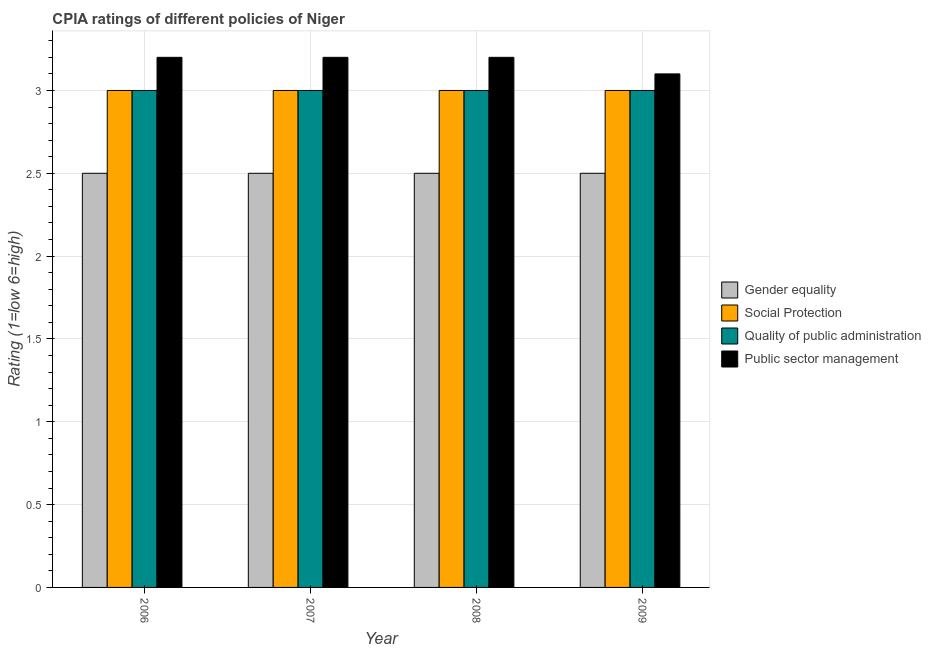How many different coloured bars are there?
Provide a short and direct response. 4. How many groups of bars are there?
Your answer should be very brief. 4. Are the number of bars on each tick of the X-axis equal?
Your response must be concise. Yes. How many bars are there on the 3rd tick from the right?
Give a very brief answer. 4. What is the label of the 2nd group of bars from the left?
Ensure brevity in your answer.  2007. What is the cpia rating of social protection in 2009?
Provide a short and direct response. 3. Across all years, what is the maximum cpia rating of public sector management?
Your response must be concise. 3.2. Across all years, what is the minimum cpia rating of gender equality?
Provide a succinct answer. 2.5. In which year was the cpia rating of social protection maximum?
Your answer should be very brief. 2006. What is the total cpia rating of quality of public administration in the graph?
Keep it short and to the point. 12. What is the average cpia rating of gender equality per year?
Offer a terse response. 2.5. In the year 2007, what is the difference between the cpia rating of gender equality and cpia rating of quality of public administration?
Offer a terse response. 0. Is the difference between the cpia rating of quality of public administration in 2006 and 2008 greater than the difference between the cpia rating of gender equality in 2006 and 2008?
Your answer should be very brief. No. What is the difference between the highest and the second highest cpia rating of public sector management?
Keep it short and to the point. 0. Is the sum of the cpia rating of quality of public administration in 2008 and 2009 greater than the maximum cpia rating of social protection across all years?
Make the answer very short. Yes. Is it the case that in every year, the sum of the cpia rating of social protection and cpia rating of public sector management is greater than the sum of cpia rating of quality of public administration and cpia rating of gender equality?
Your answer should be very brief. No. What does the 4th bar from the left in 2006 represents?
Make the answer very short. Public sector management. What does the 1st bar from the right in 2006 represents?
Give a very brief answer. Public sector management. How many bars are there?
Provide a short and direct response. 16. Are all the bars in the graph horizontal?
Your response must be concise. No. How many years are there in the graph?
Your answer should be very brief. 4. Are the values on the major ticks of Y-axis written in scientific E-notation?
Offer a very short reply. No. Does the graph contain any zero values?
Offer a very short reply. No. Where does the legend appear in the graph?
Your answer should be very brief. Center right. How are the legend labels stacked?
Offer a very short reply. Vertical. What is the title of the graph?
Make the answer very short. CPIA ratings of different policies of Niger. Does "Coal" appear as one of the legend labels in the graph?
Keep it short and to the point. No. What is the Rating (1=low 6=high) in Quality of public administration in 2006?
Give a very brief answer. 3. What is the Rating (1=low 6=high) in Gender equality in 2007?
Offer a very short reply. 2.5. What is the Rating (1=low 6=high) in Gender equality in 2008?
Offer a very short reply. 2.5. What is the Rating (1=low 6=high) in Quality of public administration in 2008?
Provide a succinct answer. 3. What is the Rating (1=low 6=high) in Public sector management in 2008?
Your answer should be compact. 3.2. What is the Rating (1=low 6=high) in Quality of public administration in 2009?
Your response must be concise. 3. Across all years, what is the maximum Rating (1=low 6=high) of Gender equality?
Your response must be concise. 2.5. Across all years, what is the maximum Rating (1=low 6=high) of Public sector management?
Give a very brief answer. 3.2. Across all years, what is the minimum Rating (1=low 6=high) of Quality of public administration?
Your answer should be very brief. 3. What is the total Rating (1=low 6=high) of Social Protection in the graph?
Provide a short and direct response. 12. What is the total Rating (1=low 6=high) of Quality of public administration in the graph?
Keep it short and to the point. 12. What is the total Rating (1=low 6=high) of Public sector management in the graph?
Provide a short and direct response. 12.7. What is the difference between the Rating (1=low 6=high) in Quality of public administration in 2006 and that in 2007?
Give a very brief answer. 0. What is the difference between the Rating (1=low 6=high) of Public sector management in 2006 and that in 2007?
Offer a very short reply. 0. What is the difference between the Rating (1=low 6=high) of Gender equality in 2006 and that in 2008?
Your answer should be compact. 0. What is the difference between the Rating (1=low 6=high) of Social Protection in 2006 and that in 2008?
Offer a very short reply. 0. What is the difference between the Rating (1=low 6=high) in Gender equality in 2006 and that in 2009?
Provide a short and direct response. 0. What is the difference between the Rating (1=low 6=high) in Social Protection in 2006 and that in 2009?
Give a very brief answer. 0. What is the difference between the Rating (1=low 6=high) of Public sector management in 2006 and that in 2009?
Offer a very short reply. 0.1. What is the difference between the Rating (1=low 6=high) of Gender equality in 2007 and that in 2008?
Ensure brevity in your answer.  0. What is the difference between the Rating (1=low 6=high) of Social Protection in 2007 and that in 2008?
Provide a succinct answer. 0. What is the difference between the Rating (1=low 6=high) of Quality of public administration in 2007 and that in 2008?
Make the answer very short. 0. What is the difference between the Rating (1=low 6=high) of Gender equality in 2007 and that in 2009?
Provide a succinct answer. 0. What is the difference between the Rating (1=low 6=high) of Social Protection in 2007 and that in 2009?
Offer a terse response. 0. What is the difference between the Rating (1=low 6=high) of Public sector management in 2008 and that in 2009?
Your response must be concise. 0.1. What is the difference between the Rating (1=low 6=high) in Gender equality in 2006 and the Rating (1=low 6=high) in Social Protection in 2007?
Your answer should be very brief. -0.5. What is the difference between the Rating (1=low 6=high) of Gender equality in 2006 and the Rating (1=low 6=high) of Public sector management in 2008?
Provide a succinct answer. -0.7. What is the difference between the Rating (1=low 6=high) of Social Protection in 2006 and the Rating (1=low 6=high) of Public sector management in 2008?
Provide a short and direct response. -0.2. What is the difference between the Rating (1=low 6=high) in Gender equality in 2006 and the Rating (1=low 6=high) in Public sector management in 2009?
Ensure brevity in your answer.  -0.6. What is the difference between the Rating (1=low 6=high) in Social Protection in 2006 and the Rating (1=low 6=high) in Quality of public administration in 2009?
Keep it short and to the point. 0. What is the difference between the Rating (1=low 6=high) in Social Protection in 2006 and the Rating (1=low 6=high) in Public sector management in 2009?
Your response must be concise. -0.1. What is the difference between the Rating (1=low 6=high) in Gender equality in 2007 and the Rating (1=low 6=high) in Quality of public administration in 2008?
Ensure brevity in your answer.  -0.5. What is the difference between the Rating (1=low 6=high) in Gender equality in 2007 and the Rating (1=low 6=high) in Public sector management in 2008?
Provide a short and direct response. -0.7. What is the difference between the Rating (1=low 6=high) of Social Protection in 2007 and the Rating (1=low 6=high) of Quality of public administration in 2008?
Keep it short and to the point. 0. What is the difference between the Rating (1=low 6=high) of Quality of public administration in 2007 and the Rating (1=low 6=high) of Public sector management in 2008?
Offer a very short reply. -0.2. What is the difference between the Rating (1=low 6=high) of Gender equality in 2007 and the Rating (1=low 6=high) of Social Protection in 2009?
Offer a terse response. -0.5. What is the difference between the Rating (1=low 6=high) in Gender equality in 2007 and the Rating (1=low 6=high) in Quality of public administration in 2009?
Offer a very short reply. -0.5. What is the difference between the Rating (1=low 6=high) of Gender equality in 2007 and the Rating (1=low 6=high) of Public sector management in 2009?
Provide a short and direct response. -0.6. What is the difference between the Rating (1=low 6=high) of Quality of public administration in 2007 and the Rating (1=low 6=high) of Public sector management in 2009?
Keep it short and to the point. -0.1. What is the difference between the Rating (1=low 6=high) of Social Protection in 2008 and the Rating (1=low 6=high) of Quality of public administration in 2009?
Keep it short and to the point. 0. What is the difference between the Rating (1=low 6=high) in Social Protection in 2008 and the Rating (1=low 6=high) in Public sector management in 2009?
Keep it short and to the point. -0.1. What is the difference between the Rating (1=low 6=high) of Quality of public administration in 2008 and the Rating (1=low 6=high) of Public sector management in 2009?
Provide a short and direct response. -0.1. What is the average Rating (1=low 6=high) in Gender equality per year?
Your response must be concise. 2.5. What is the average Rating (1=low 6=high) of Social Protection per year?
Ensure brevity in your answer.  3. What is the average Rating (1=low 6=high) of Public sector management per year?
Offer a very short reply. 3.17. In the year 2006, what is the difference between the Rating (1=low 6=high) of Gender equality and Rating (1=low 6=high) of Public sector management?
Your answer should be compact. -0.7. In the year 2006, what is the difference between the Rating (1=low 6=high) of Social Protection and Rating (1=low 6=high) of Quality of public administration?
Keep it short and to the point. 0. In the year 2006, what is the difference between the Rating (1=low 6=high) of Social Protection and Rating (1=low 6=high) of Public sector management?
Offer a terse response. -0.2. In the year 2006, what is the difference between the Rating (1=low 6=high) in Quality of public administration and Rating (1=low 6=high) in Public sector management?
Provide a succinct answer. -0.2. In the year 2007, what is the difference between the Rating (1=low 6=high) of Gender equality and Rating (1=low 6=high) of Social Protection?
Provide a short and direct response. -0.5. In the year 2007, what is the difference between the Rating (1=low 6=high) in Social Protection and Rating (1=low 6=high) in Quality of public administration?
Keep it short and to the point. 0. In the year 2007, what is the difference between the Rating (1=low 6=high) of Quality of public administration and Rating (1=low 6=high) of Public sector management?
Provide a short and direct response. -0.2. In the year 2008, what is the difference between the Rating (1=low 6=high) of Gender equality and Rating (1=low 6=high) of Social Protection?
Provide a short and direct response. -0.5. In the year 2008, what is the difference between the Rating (1=low 6=high) in Gender equality and Rating (1=low 6=high) in Quality of public administration?
Offer a terse response. -0.5. In the year 2009, what is the difference between the Rating (1=low 6=high) in Social Protection and Rating (1=low 6=high) in Quality of public administration?
Ensure brevity in your answer.  0. In the year 2009, what is the difference between the Rating (1=low 6=high) in Social Protection and Rating (1=low 6=high) in Public sector management?
Make the answer very short. -0.1. In the year 2009, what is the difference between the Rating (1=low 6=high) of Quality of public administration and Rating (1=low 6=high) of Public sector management?
Provide a short and direct response. -0.1. What is the ratio of the Rating (1=low 6=high) of Social Protection in 2006 to that in 2007?
Offer a very short reply. 1. What is the ratio of the Rating (1=low 6=high) in Quality of public administration in 2006 to that in 2007?
Provide a succinct answer. 1. What is the ratio of the Rating (1=low 6=high) of Gender equality in 2006 to that in 2008?
Keep it short and to the point. 1. What is the ratio of the Rating (1=low 6=high) in Social Protection in 2006 to that in 2008?
Make the answer very short. 1. What is the ratio of the Rating (1=low 6=high) of Quality of public administration in 2006 to that in 2008?
Your answer should be very brief. 1. What is the ratio of the Rating (1=low 6=high) in Social Protection in 2006 to that in 2009?
Keep it short and to the point. 1. What is the ratio of the Rating (1=low 6=high) in Public sector management in 2006 to that in 2009?
Make the answer very short. 1.03. What is the ratio of the Rating (1=low 6=high) in Social Protection in 2007 to that in 2008?
Keep it short and to the point. 1. What is the ratio of the Rating (1=low 6=high) of Quality of public administration in 2007 to that in 2008?
Provide a succinct answer. 1. What is the ratio of the Rating (1=low 6=high) of Gender equality in 2007 to that in 2009?
Your response must be concise. 1. What is the ratio of the Rating (1=low 6=high) in Quality of public administration in 2007 to that in 2009?
Your answer should be compact. 1. What is the ratio of the Rating (1=low 6=high) of Public sector management in 2007 to that in 2009?
Your answer should be compact. 1.03. What is the ratio of the Rating (1=low 6=high) in Social Protection in 2008 to that in 2009?
Provide a short and direct response. 1. What is the ratio of the Rating (1=low 6=high) of Public sector management in 2008 to that in 2009?
Keep it short and to the point. 1.03. What is the difference between the highest and the second highest Rating (1=low 6=high) in Social Protection?
Offer a very short reply. 0. What is the difference between the highest and the lowest Rating (1=low 6=high) of Gender equality?
Provide a short and direct response. 0. What is the difference between the highest and the lowest Rating (1=low 6=high) of Public sector management?
Provide a succinct answer. 0.1. 